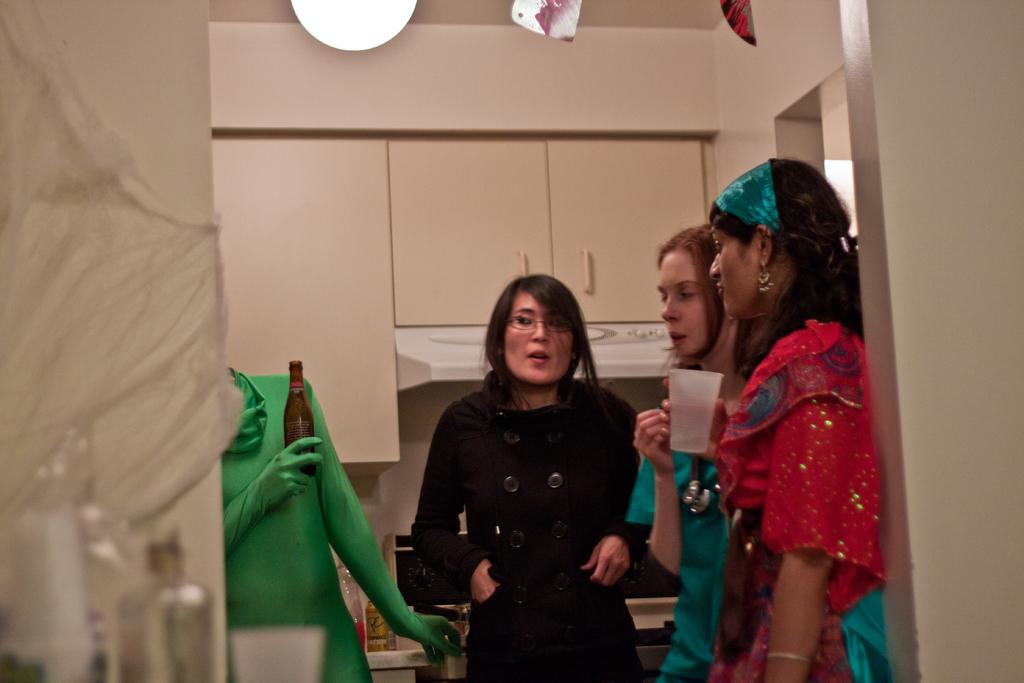What are the people in the center of the image doing? The people are standing in the center of the image and holding glasses. What is the purpose of the glasses they are holding? The glasses are likely for drinking, as there is a wine bottle in the image. What can be seen in the background of the image? There is a wall, a cupboard, a light, and additional objects in the background. Can you describe the light in the background? The light is likely a source of illumination for the room, but its specific type or style cannot be determined from the image. What nation is represented by the flag hanging on the wall in the image? There is no flag visible in the image, so it is not possible to determine which nation might be represented. 